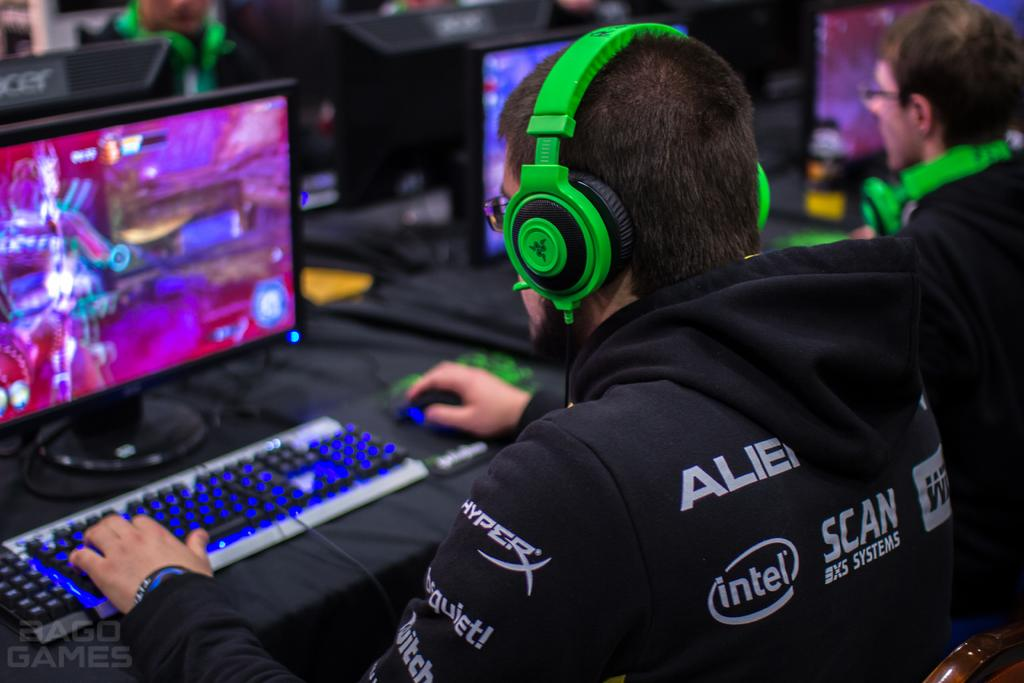<image>
Create a compact narrative representing the image presented. Man wearing green headphones and a sweat that says intel on it. 